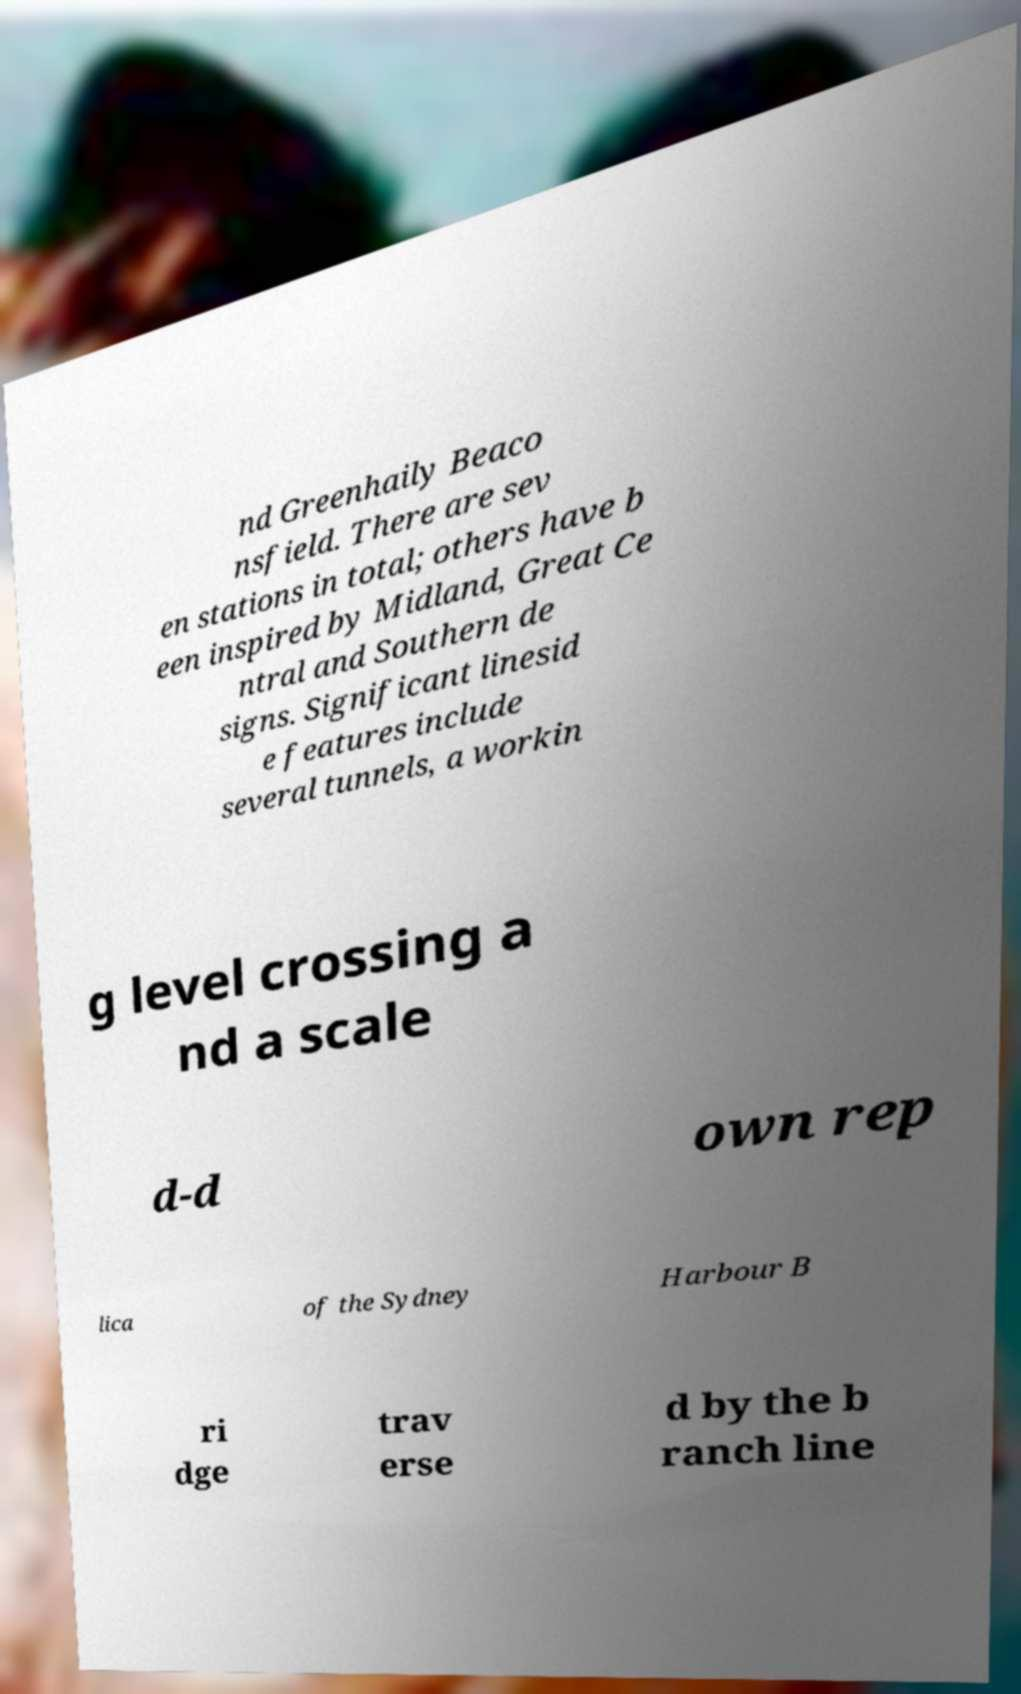Please identify and transcribe the text found in this image. nd Greenhaily Beaco nsfield. There are sev en stations in total; others have b een inspired by Midland, Great Ce ntral and Southern de signs. Significant linesid e features include several tunnels, a workin g level crossing a nd a scale d-d own rep lica of the Sydney Harbour B ri dge trav erse d by the b ranch line 